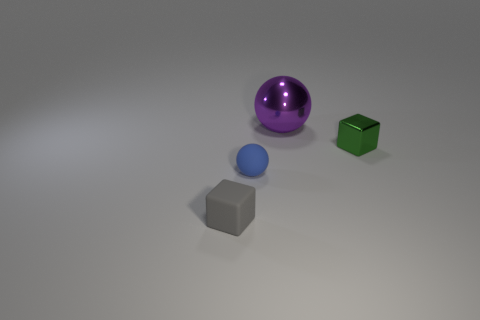Add 4 small green metal balls. How many objects exist? 8 Add 2 purple metal things. How many purple metal things are left? 3 Add 2 large red cubes. How many large red cubes exist? 2 Subtract 0 brown cubes. How many objects are left? 4 Subtract all green blocks. Subtract all blue matte spheres. How many objects are left? 2 